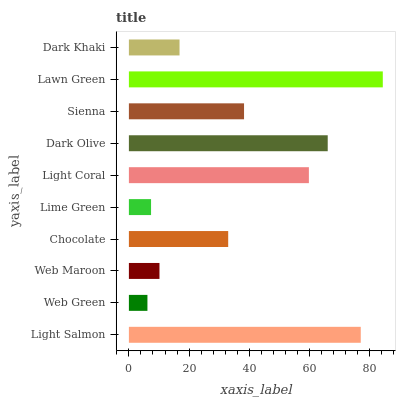Is Web Green the minimum?
Answer yes or no. Yes. Is Lawn Green the maximum?
Answer yes or no. Yes. Is Web Maroon the minimum?
Answer yes or no. No. Is Web Maroon the maximum?
Answer yes or no. No. Is Web Maroon greater than Web Green?
Answer yes or no. Yes. Is Web Green less than Web Maroon?
Answer yes or no. Yes. Is Web Green greater than Web Maroon?
Answer yes or no. No. Is Web Maroon less than Web Green?
Answer yes or no. No. Is Sienna the high median?
Answer yes or no. Yes. Is Chocolate the low median?
Answer yes or no. Yes. Is Dark Olive the high median?
Answer yes or no. No. Is Lime Green the low median?
Answer yes or no. No. 